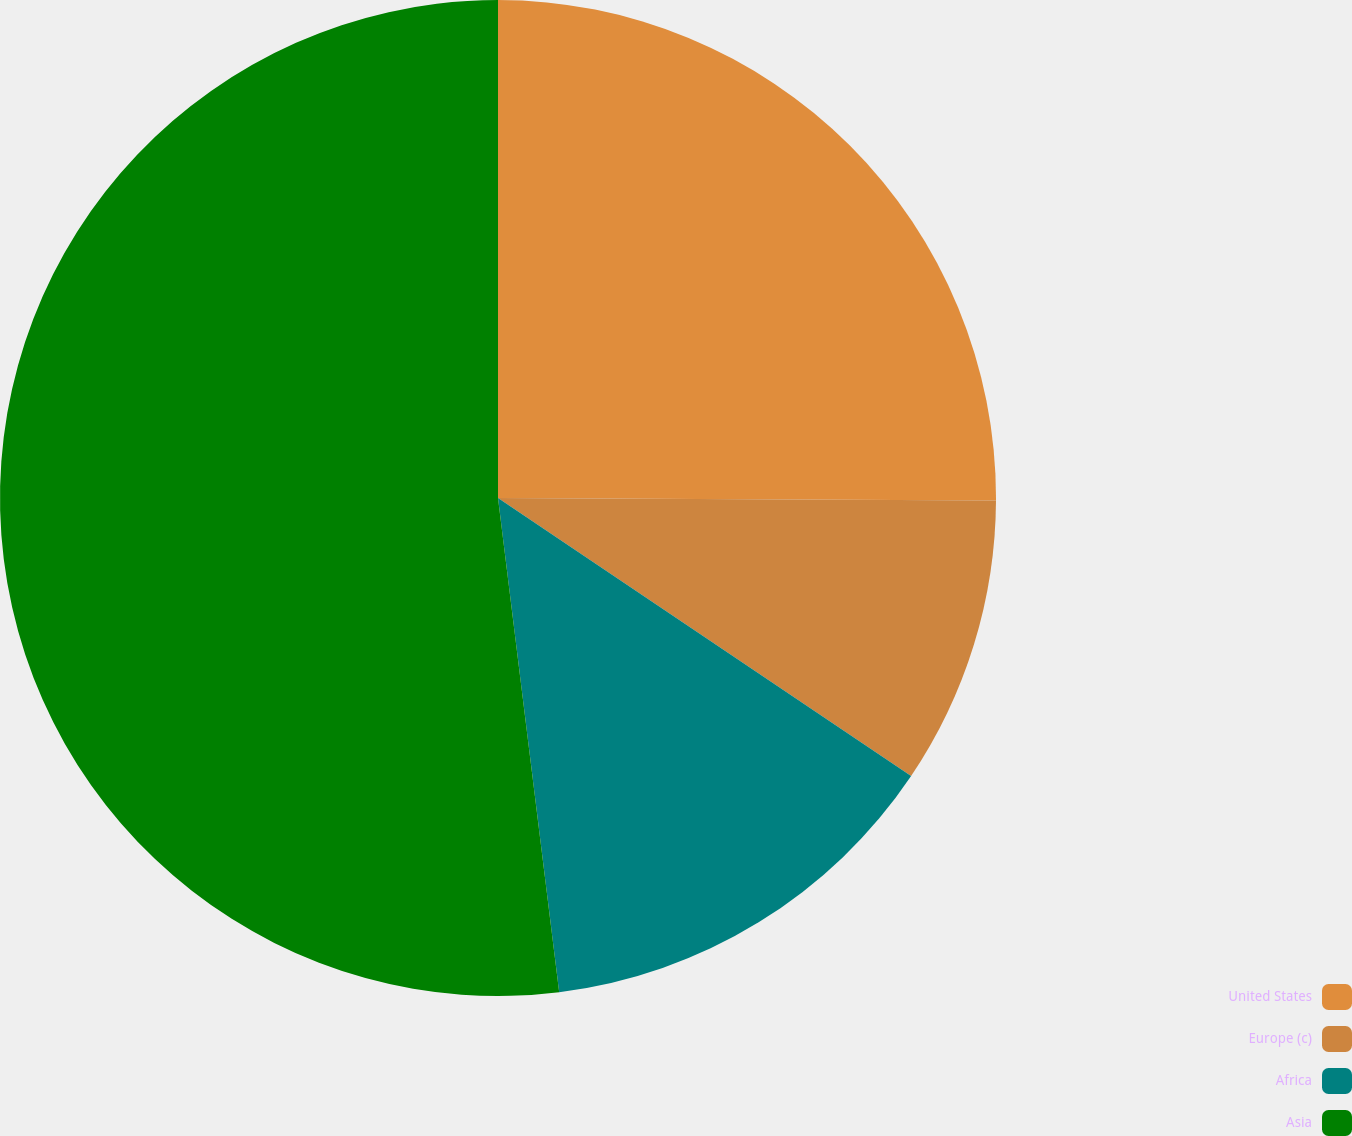Convert chart to OTSL. <chart><loc_0><loc_0><loc_500><loc_500><pie_chart><fcel>United States<fcel>Europe (c)<fcel>Africa<fcel>Asia<nl><fcel>25.08%<fcel>9.35%<fcel>13.61%<fcel>51.96%<nl></chart> 